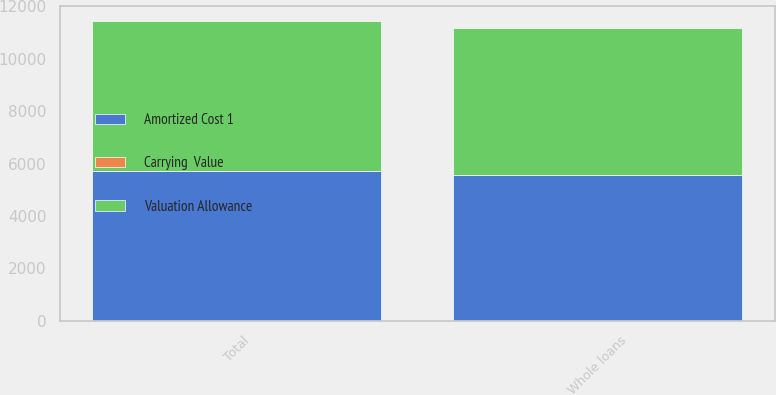Convert chart. <chart><loc_0><loc_0><loc_500><loc_500><stacked_bar_chart><ecel><fcel>Whole loans<fcel>Total<nl><fcel>Valuation Allowance<fcel>5580<fcel>5716<nl><fcel>Carrying  Value<fcel>19<fcel>19<nl><fcel>Amortized Cost 1<fcel>5561<fcel>5697<nl></chart> 